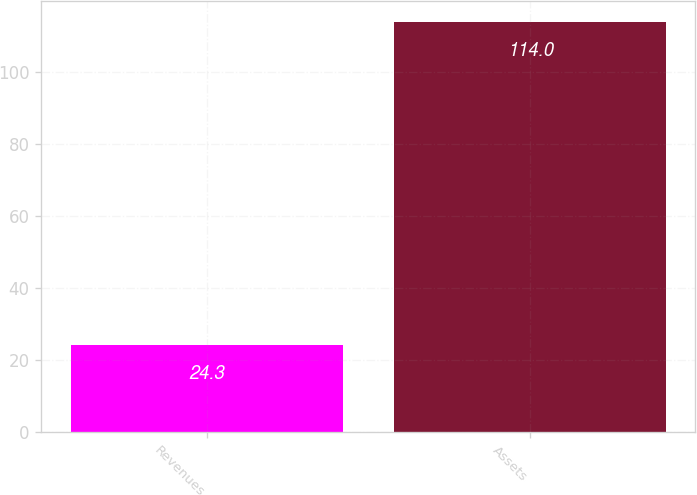<chart> <loc_0><loc_0><loc_500><loc_500><bar_chart><fcel>Revenues<fcel>Assets<nl><fcel>24.3<fcel>114<nl></chart> 